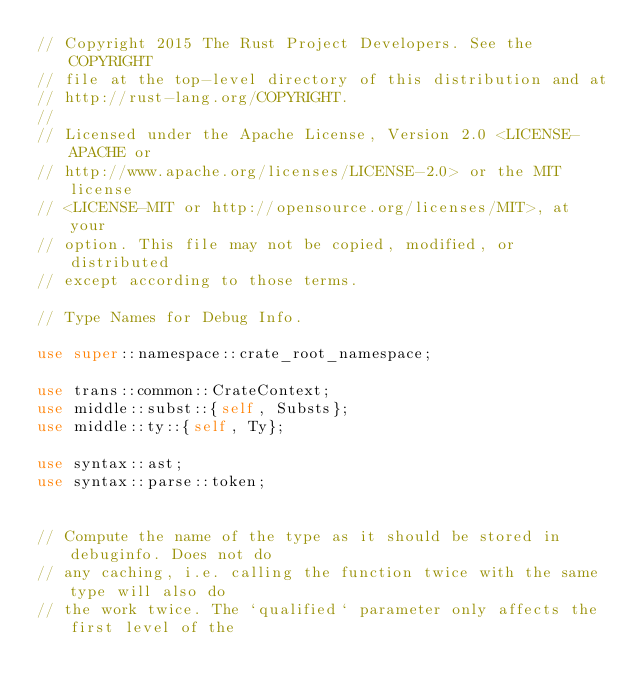Convert code to text. <code><loc_0><loc_0><loc_500><loc_500><_Rust_>// Copyright 2015 The Rust Project Developers. See the COPYRIGHT
// file at the top-level directory of this distribution and at
// http://rust-lang.org/COPYRIGHT.
//
// Licensed under the Apache License, Version 2.0 <LICENSE-APACHE or
// http://www.apache.org/licenses/LICENSE-2.0> or the MIT license
// <LICENSE-MIT or http://opensource.org/licenses/MIT>, at your
// option. This file may not be copied, modified, or distributed
// except according to those terms.

// Type Names for Debug Info.

use super::namespace::crate_root_namespace;

use trans::common::CrateContext;
use middle::subst::{self, Substs};
use middle::ty::{self, Ty};

use syntax::ast;
use syntax::parse::token;


// Compute the name of the type as it should be stored in debuginfo. Does not do
// any caching, i.e. calling the function twice with the same type will also do
// the work twice. The `qualified` parameter only affects the first level of the</code> 